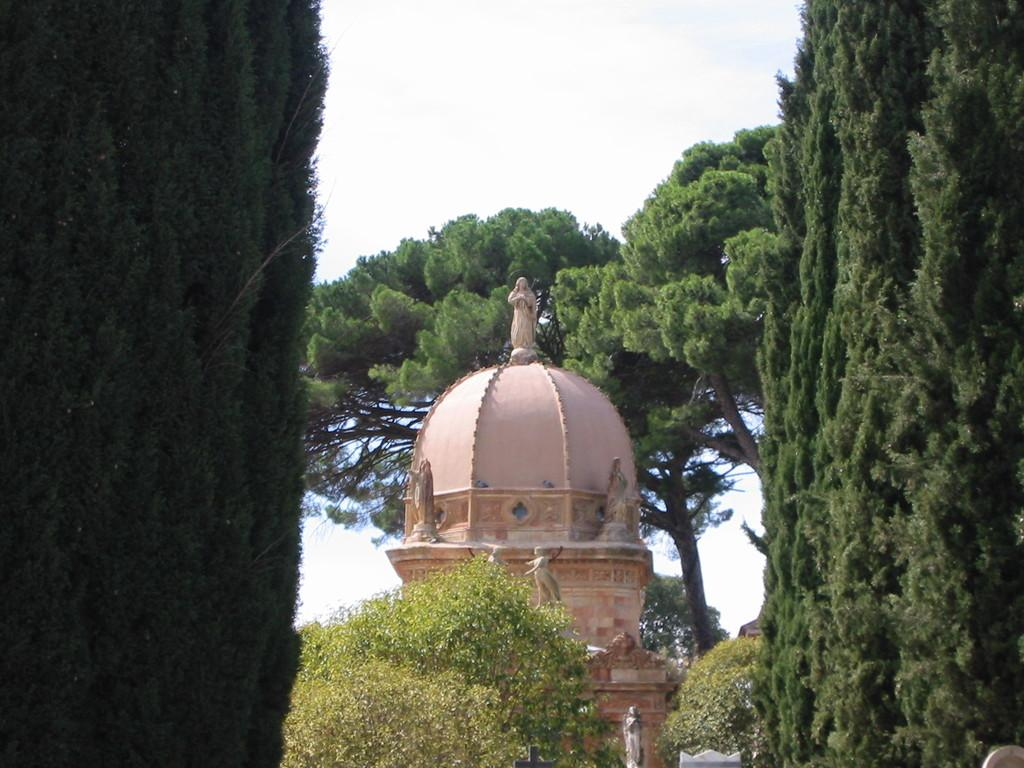What type of vegetation is present on the left side of the image? There are trees on the left side of the image. What type of vegetation is present on the right side of the image? There are trees on the right side of the image. What type of structure can be seen in the image? There is a dome construction in the image. What is visible in the background of the image? The sky is visible in the image. Can you see any attempts to climb the trees in the image? There is no indication of anyone attempting to climb the trees in the image. Is there a zipper visible on any of the trees in the image? There are no zippers present on the trees in the image. 